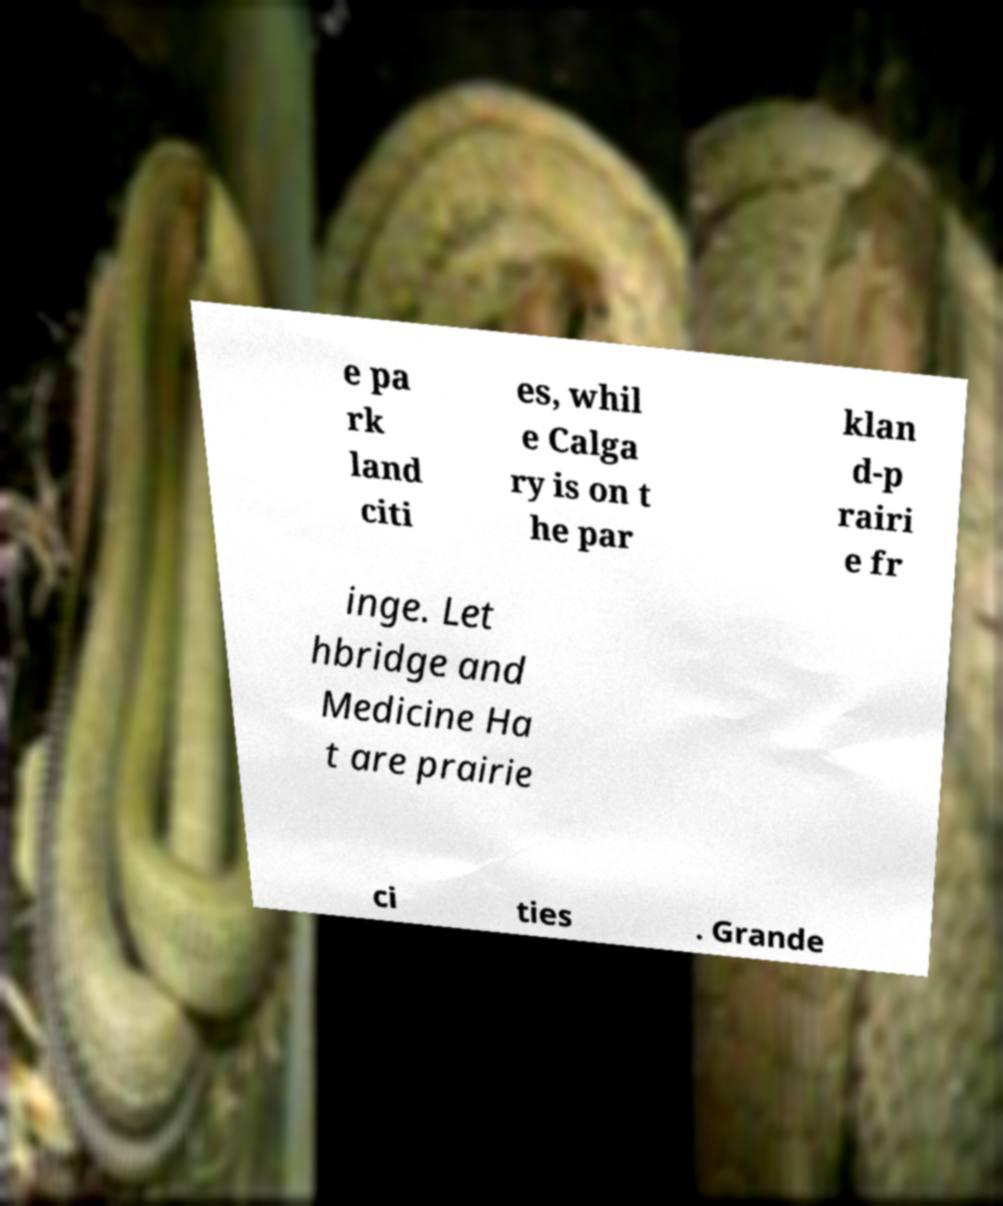For documentation purposes, I need the text within this image transcribed. Could you provide that? e pa rk land citi es, whil e Calga ry is on t he par klan d-p rairi e fr inge. Let hbridge and Medicine Ha t are prairie ci ties . Grande 